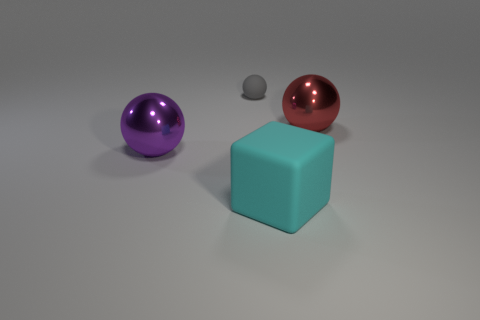What number of other objects are there of the same shape as the small object?
Make the answer very short. 2. There is a metallic object to the right of the purple sphere; does it have the same size as the rubber object that is behind the purple shiny object?
Keep it short and to the point. No. Is the number of gray spheres right of the large cyan object greater than the number of large metallic things?
Provide a succinct answer. No. Is the tiny gray rubber object the same shape as the red object?
Your response must be concise. Yes. What number of small gray objects are made of the same material as the small ball?
Your answer should be compact. 0. What is the size of the other purple thing that is the same shape as the tiny thing?
Provide a succinct answer. Large. Do the cyan block and the red object have the same size?
Make the answer very short. Yes. There is a object right of the matte object that is in front of the sphere to the right of the large cube; what is its shape?
Keep it short and to the point. Sphere. There is another metallic object that is the same shape as the red thing; what is its color?
Provide a succinct answer. Purple. What is the size of the object that is both behind the cyan thing and in front of the red object?
Your response must be concise. Large. 